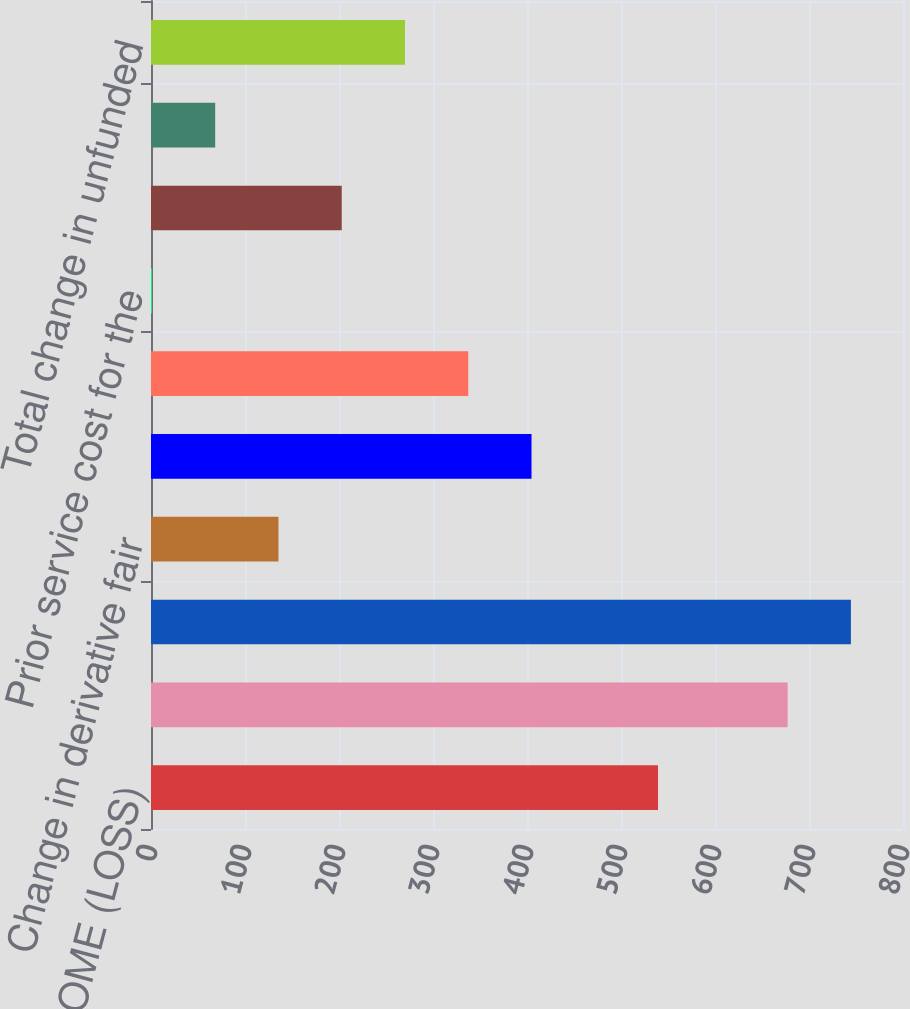<chart> <loc_0><loc_0><loc_500><loc_500><bar_chart><fcel>NET INCOME (LOSS)<fcel>Foreign currency translation<fcel>Total foreign currency<fcel>Change in derivative fair<fcel>Reclassification to earnings<fcel>Total change in fair value of<fcel>Prior service cost for the<fcel>Change in pension adjustments<fcel>Reclassification of earnings<fcel>Total change in unfunded<nl><fcel>539.4<fcel>677.3<fcel>744.6<fcel>135.6<fcel>404.8<fcel>337.5<fcel>1<fcel>202.9<fcel>68.3<fcel>270.2<nl></chart> 